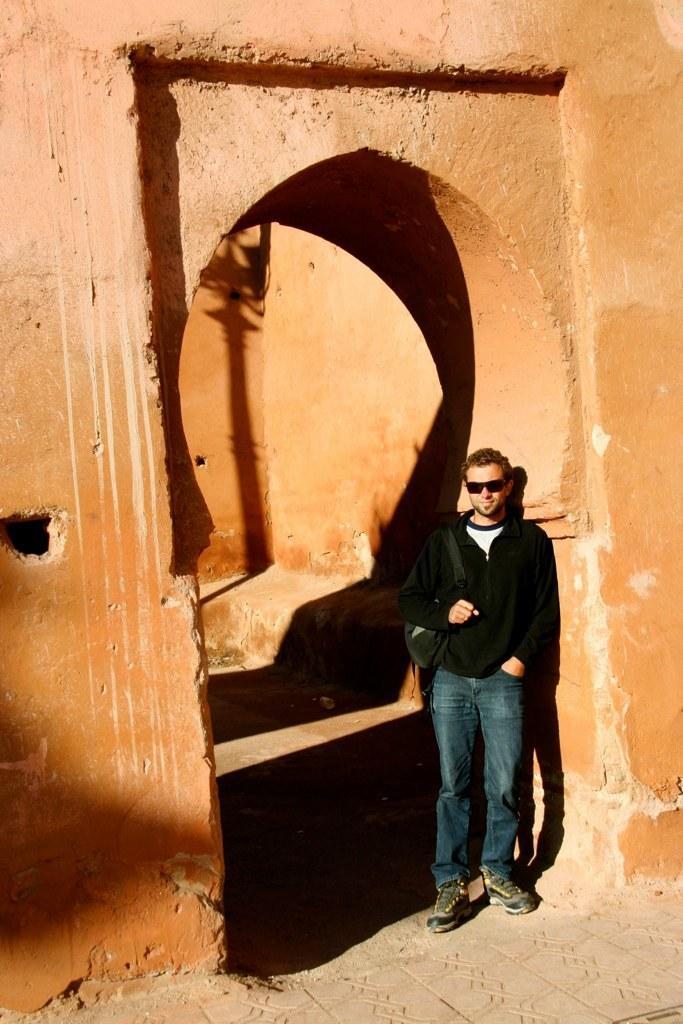How would you summarize this image in a sentence or two? In this image I can see a man wearing black color jacket, jeans, standing and leaning to the wall. He is smiling and giving pose for the picture. Here I can see a wall which is in red color. 